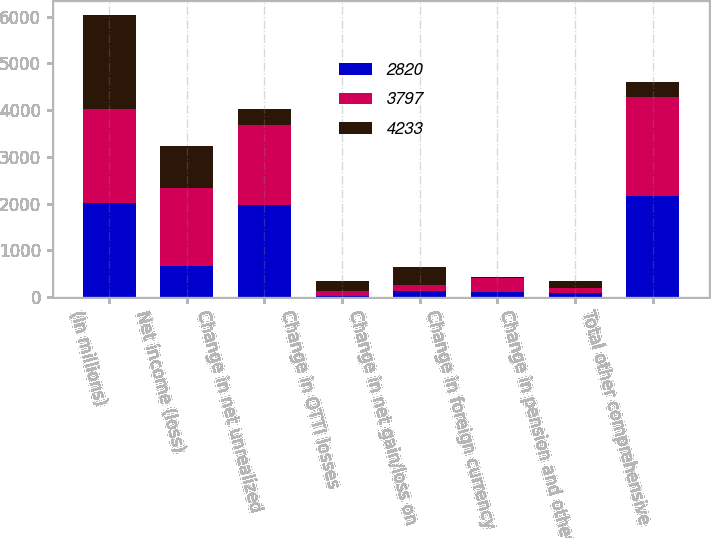Convert chart. <chart><loc_0><loc_0><loc_500><loc_500><stacked_bar_chart><ecel><fcel>(In millions)<fcel>Net income (loss)<fcel>Change in net unrealized<fcel>Change in OTTI losses<fcel>Change in net gain/loss on<fcel>Change in foreign currency<fcel>Change in pension and other<fcel>Total other comprehensive<nl><fcel>2820<fcel>2011<fcel>662<fcel>1979<fcel>9<fcel>131<fcel>112<fcel>73<fcel>2158<nl><fcel>3797<fcel>2010<fcel>1680<fcel>1707<fcel>116<fcel>128<fcel>289<fcel>123<fcel>2117<nl><fcel>4233<fcel>2009<fcel>887<fcel>338<fcel>224<fcel>387<fcel>23<fcel>155<fcel>338<nl></chart> 